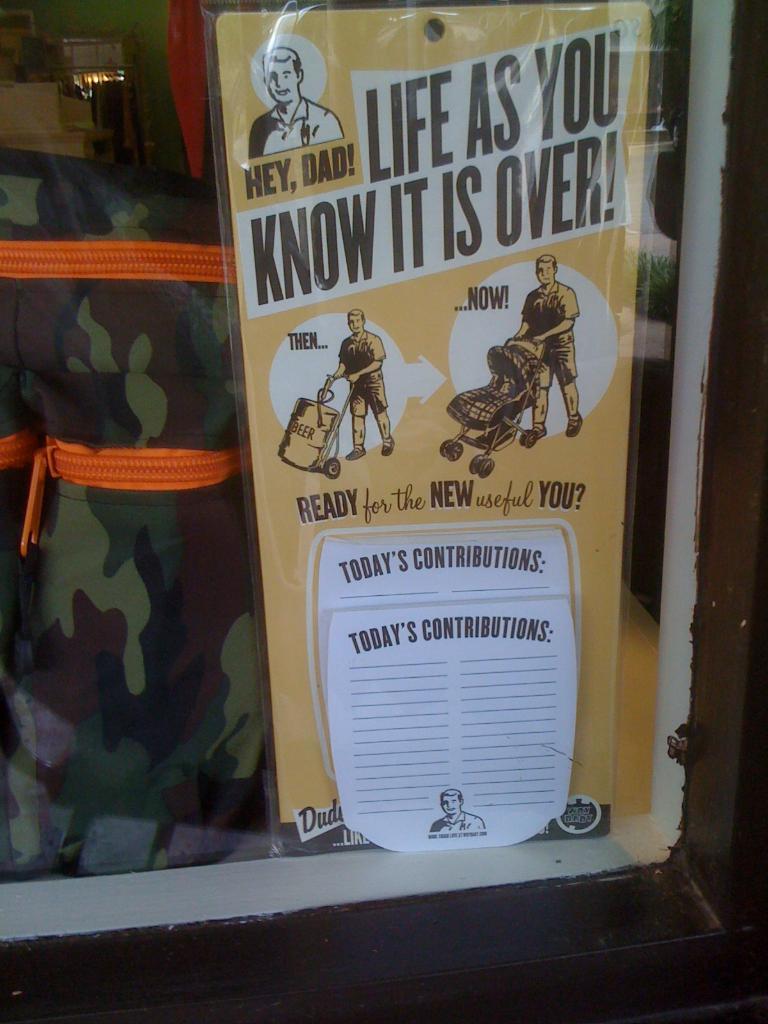What is over?
Your answer should be very brief. Life as you know it. 